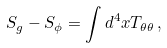<formula> <loc_0><loc_0><loc_500><loc_500>S _ { g } - S _ { \phi } = \int d ^ { 4 } x T _ { \theta \theta } \, ,</formula> 